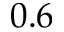Convert formula to latex. <formula><loc_0><loc_0><loc_500><loc_500>0 . 6</formula> 